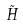<formula> <loc_0><loc_0><loc_500><loc_500>\tilde { H }</formula> 